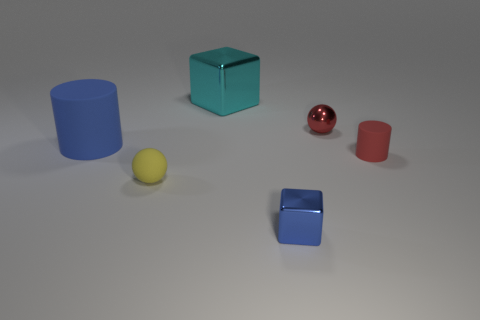There is a rubber object that is the same color as the tiny shiny cube; what is its size?
Your response must be concise. Large. What number of other objects are the same size as the red metallic ball?
Keep it short and to the point. 3. There is a tiny matte thing behind the rubber sphere; does it have the same color as the small shiny sphere?
Offer a very short reply. Yes. Are there more blue things to the left of the tiny blue thing than large blue metal things?
Ensure brevity in your answer.  Yes. Is there any other thing that has the same color as the tiny metallic cube?
Ensure brevity in your answer.  Yes. There is a object behind the small ball on the right side of the large cyan object; what shape is it?
Your answer should be compact. Cube. Is the number of metal balls greater than the number of small red things?
Keep it short and to the point. No. How many matte objects are both right of the tiny yellow matte ball and to the left of the small blue object?
Offer a very short reply. 0. There is a sphere that is behind the big cylinder; how many small metal objects are in front of it?
Offer a very short reply. 1. How many objects are either objects that are right of the yellow matte ball or blue objects in front of the blue rubber cylinder?
Keep it short and to the point. 4. 